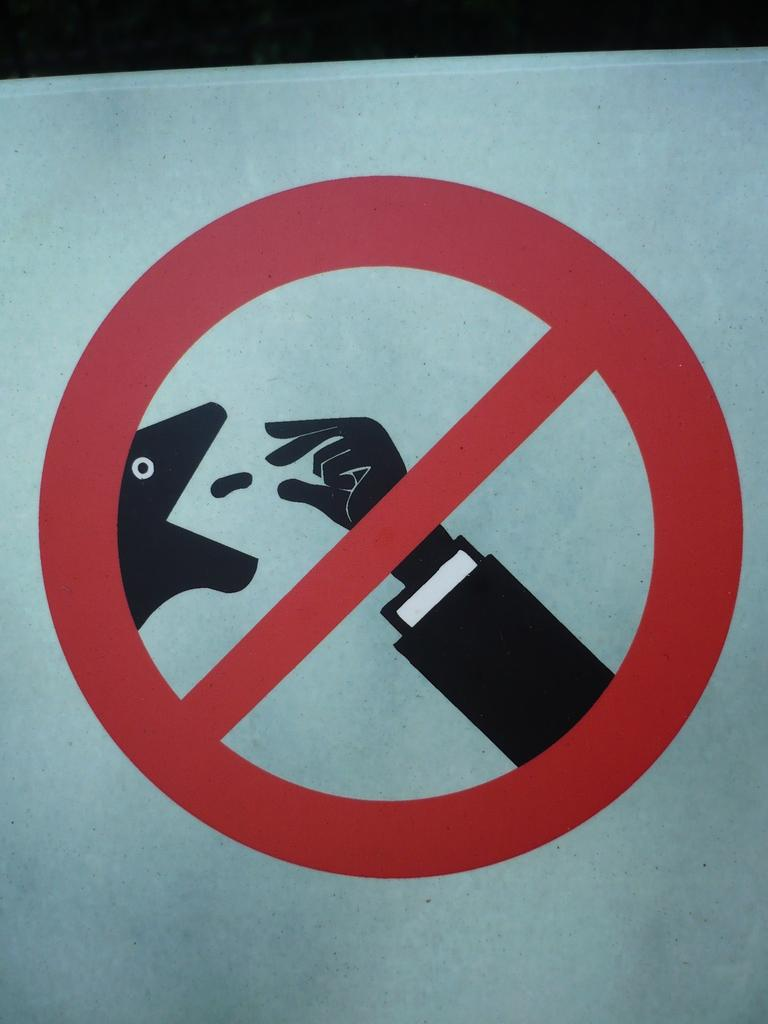What is present in the image that provides information or direction? There is a sign board in the image. Can you describe the lighting or color of the top part of the image? The top part of the image appears to be dark. What type of sponge can be seen cleaning the sign board in the image? There is no sponge present in the image, nor is there any cleaning activity taking place. 